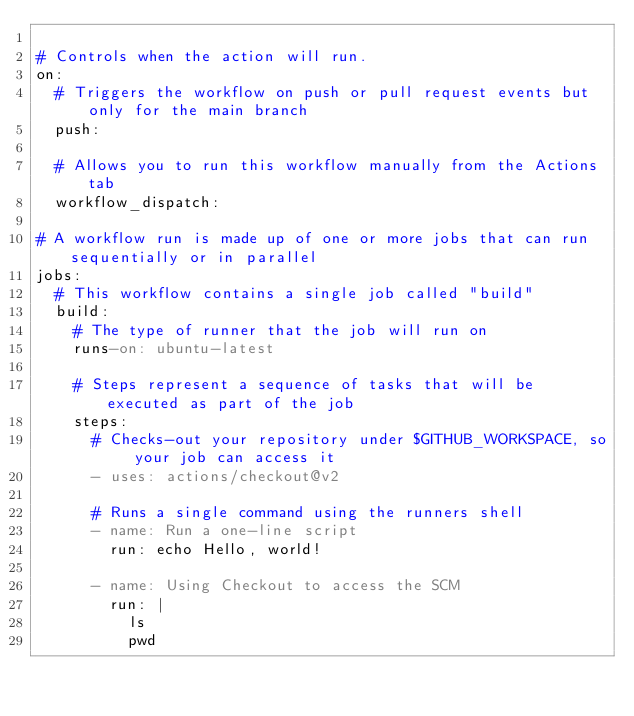Convert code to text. <code><loc_0><loc_0><loc_500><loc_500><_YAML_>
# Controls when the action will run. 
on:
  # Triggers the workflow on push or pull request events but only for the main branch
  push:

  # Allows you to run this workflow manually from the Actions tab
  workflow_dispatch:

# A workflow run is made up of one or more jobs that can run sequentially or in parallel
jobs:
  # This workflow contains a single job called "build"
  build:
    # The type of runner that the job will run on
    runs-on: ubuntu-latest

    # Steps represent a sequence of tasks that will be executed as part of the job
    steps:
      # Checks-out your repository under $GITHUB_WORKSPACE, so your job can access it
      - uses: actions/checkout@v2

      # Runs a single command using the runners shell
      - name: Run a one-line script
        run: echo Hello, world!
      
      - name: Using Checkout to access the SCM
        run: |
          ls
          pwd
</code> 